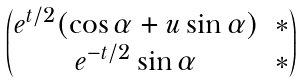Convert formula to latex. <formula><loc_0><loc_0><loc_500><loc_500>\begin{pmatrix} e ^ { t / 2 } ( \cos \alpha + u \sin \alpha ) & \ast \\ e ^ { - t / 2 } \sin \alpha & \ast \end{pmatrix}</formula> 